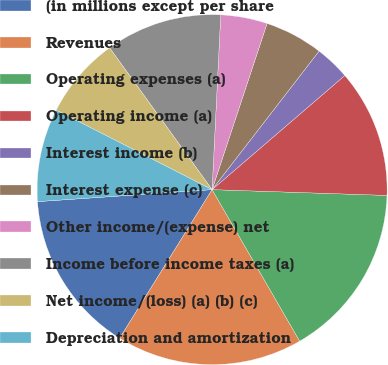Convert chart. <chart><loc_0><loc_0><loc_500><loc_500><pie_chart><fcel>(in millions except per share<fcel>Revenues<fcel>Operating expenses (a)<fcel>Operating income (a)<fcel>Interest income (b)<fcel>Interest expense (c)<fcel>Other income/(expense) net<fcel>Income before income taxes (a)<fcel>Net income/(loss) (a) (b) (c)<fcel>Depreciation and amortization<nl><fcel>15.05%<fcel>17.2%<fcel>16.13%<fcel>11.83%<fcel>3.23%<fcel>5.38%<fcel>4.3%<fcel>10.75%<fcel>7.53%<fcel>8.6%<nl></chart> 